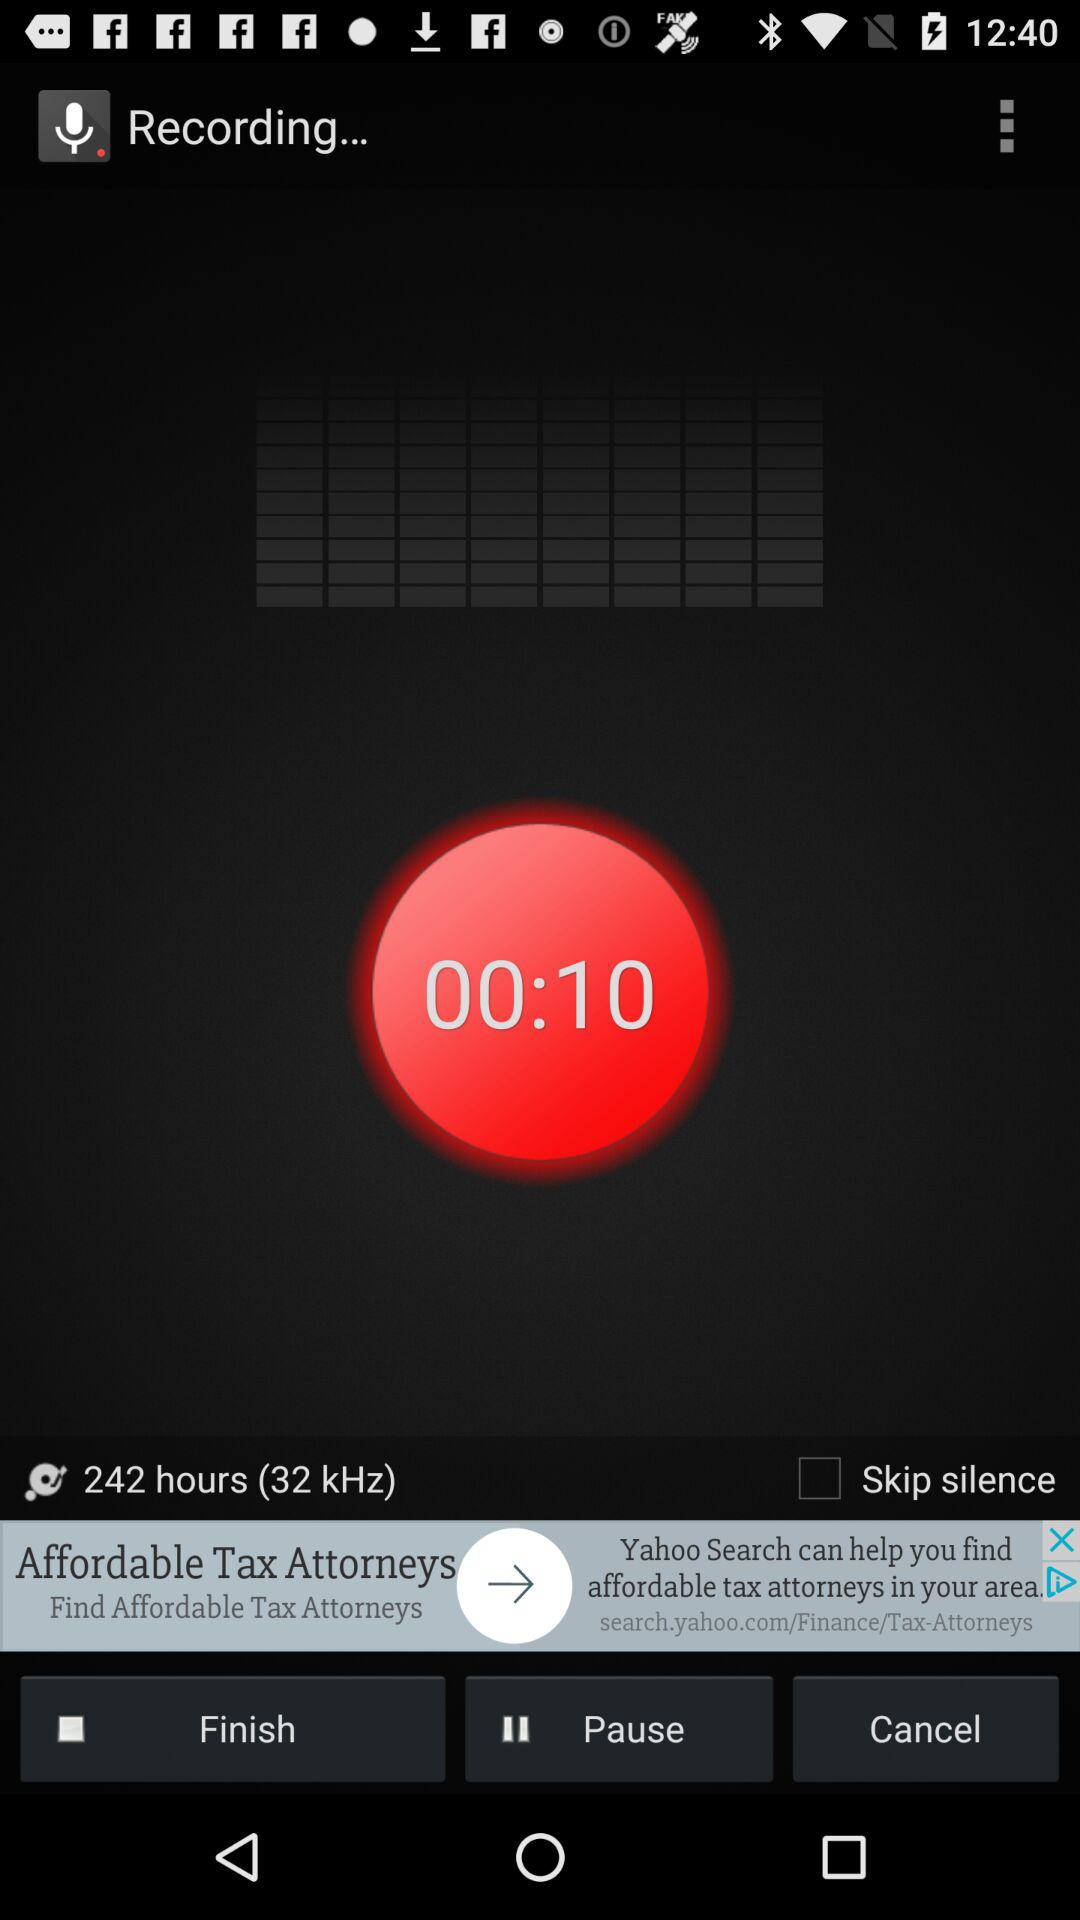What is the number of hours? The number of hours is 242. 